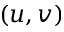<formula> <loc_0><loc_0><loc_500><loc_500>( u , v )</formula> 